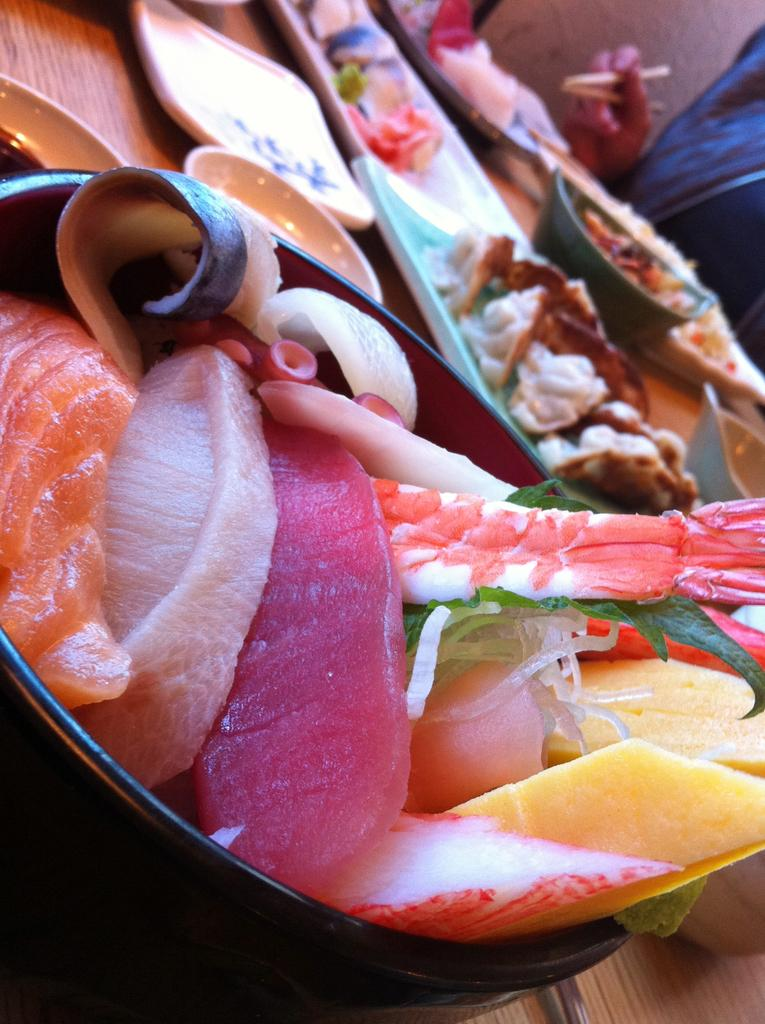What type of containers are visible in the image? There are bowls and plates in the image. What are the bowls and plates used for? Food items are present on the bowls and plates. What is the surface on which the bowls and plates are placed? The bowls and plates are on a wooden surface. What is the person in the image holding? The person is holding chopsticks in their hand. What type of nerve can be seen in the image? There are no nerves visible in the image; it features bowls, plates, food items, and a person holding chopsticks. What is the son doing in the image? There is no mention of a son or any other person besides the one holding chopsticks in the image. 